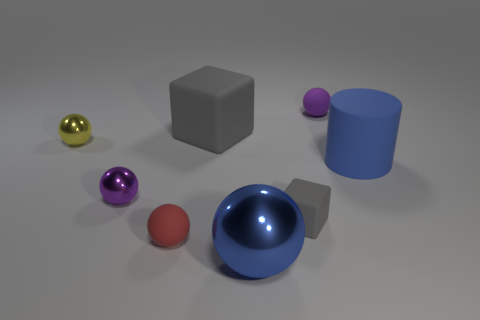Subtract all matte spheres. How many spheres are left? 3 Subtract all red balls. How many balls are left? 4 Add 1 big metal balls. How many objects exist? 9 Subtract all red cylinders. How many purple balls are left? 2 Subtract 1 blocks. How many blocks are left? 1 Subtract all balls. How many objects are left? 3 Subtract all small purple matte things. Subtract all large blue things. How many objects are left? 5 Add 6 tiny yellow spheres. How many tiny yellow spheres are left? 7 Add 7 small green things. How many small green things exist? 7 Subtract 1 yellow balls. How many objects are left? 7 